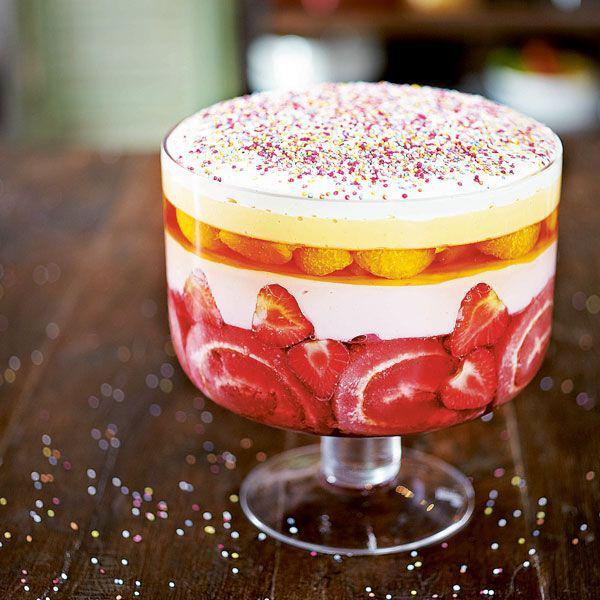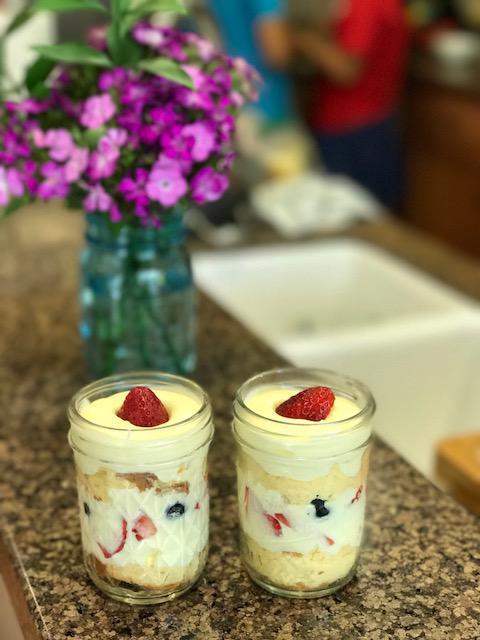The first image is the image on the left, the second image is the image on the right. Assess this claim about the two images: "An image shows at least two layered desserts served in clear non-footed glasses and each garnished with a single red berry.". Correct or not? Answer yes or no. Yes. The first image is the image on the left, the second image is the image on the right. Examine the images to the left and right. Is the description "The dessert in the image on the left is served in a single sized serving." accurate? Answer yes or no. No. 